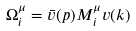<formula> <loc_0><loc_0><loc_500><loc_500>\Omega _ { i } ^ { \mu } = \bar { v } ( p ) M _ { i } ^ { \mu } v ( k )</formula> 